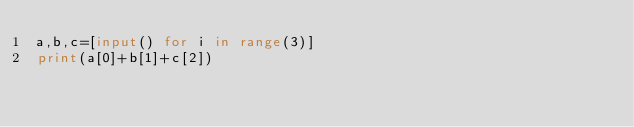Convert code to text. <code><loc_0><loc_0><loc_500><loc_500><_Python_>a,b,c=[input() for i in range(3)]
print(a[0]+b[1]+c[2])</code> 